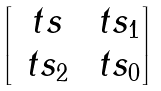<formula> <loc_0><loc_0><loc_500><loc_500>\begin{bmatrix} \ t s & \ t s _ { 1 } \\ \ t s _ { 2 } & \ t s _ { 0 } \end{bmatrix}</formula> 